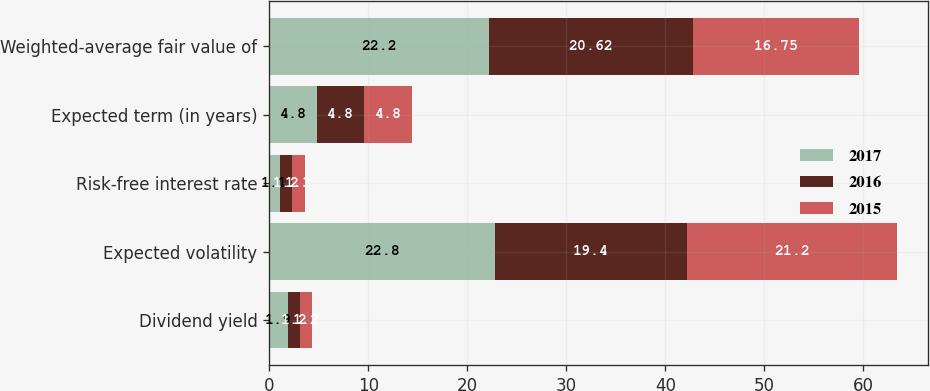Convert chart. <chart><loc_0><loc_0><loc_500><loc_500><stacked_bar_chart><ecel><fcel>Dividend yield<fcel>Expected volatility<fcel>Risk-free interest rate<fcel>Expected term (in years)<fcel>Weighted-average fair value of<nl><fcel>2017<fcel>1.9<fcel>22.8<fcel>1.1<fcel>4.8<fcel>22.2<nl><fcel>2016<fcel>1.2<fcel>19.4<fcel>1.2<fcel>4.8<fcel>20.62<nl><fcel>2015<fcel>1.2<fcel>21.2<fcel>1.3<fcel>4.8<fcel>16.75<nl></chart> 